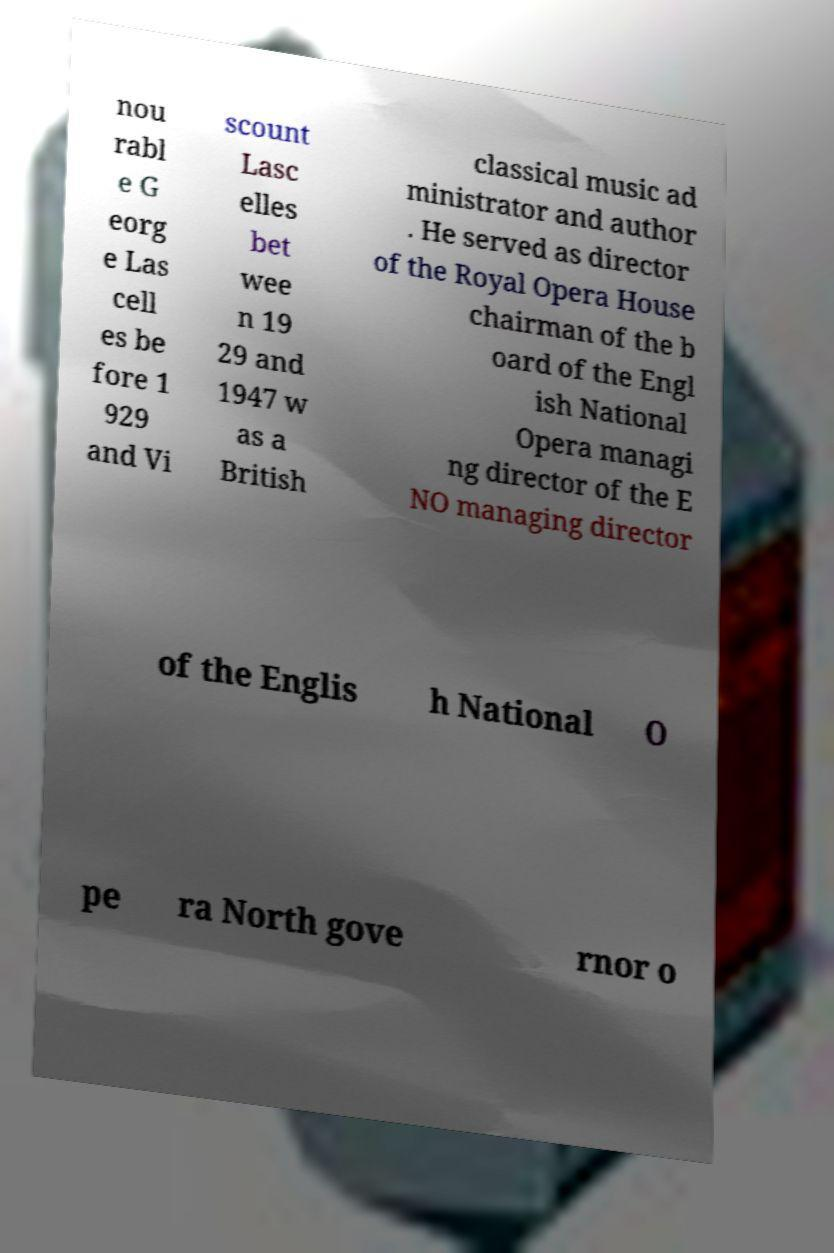Can you read and provide the text displayed in the image?This photo seems to have some interesting text. Can you extract and type it out for me? nou rabl e G eorg e Las cell es be fore 1 929 and Vi scount Lasc elles bet wee n 19 29 and 1947 w as a British classical music ad ministrator and author . He served as director of the Royal Opera House chairman of the b oard of the Engl ish National Opera managi ng director of the E NO managing director of the Englis h National O pe ra North gove rnor o 